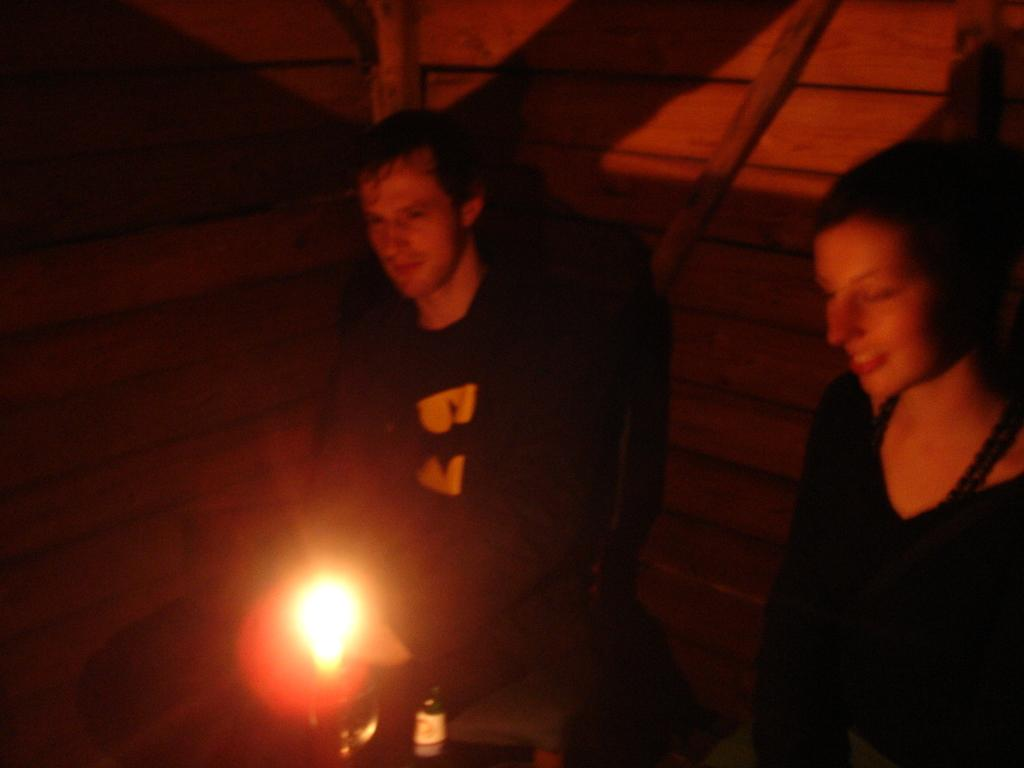How many people are in the image? There are two persons in the image. What is the source of light in the image? There is light in front of the people. What object is in front of the people? There is an object in front of the people. What type of wall is visible behind the people? There is a wooden wall behind the people. What type of record can be seen on the wooden wall behind the people? There is no record present in the image; only the wooden wall is visible behind the people. 